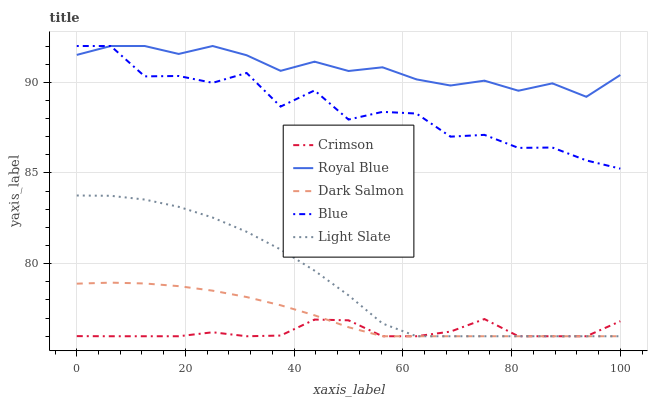Does Crimson have the minimum area under the curve?
Answer yes or no. Yes. Does Royal Blue have the maximum area under the curve?
Answer yes or no. Yes. Does Light Slate have the minimum area under the curve?
Answer yes or no. No. Does Light Slate have the maximum area under the curve?
Answer yes or no. No. Is Dark Salmon the smoothest?
Answer yes or no. Yes. Is Blue the roughest?
Answer yes or no. Yes. Is Royal Blue the smoothest?
Answer yes or no. No. Is Royal Blue the roughest?
Answer yes or no. No. Does Crimson have the lowest value?
Answer yes or no. Yes. Does Royal Blue have the lowest value?
Answer yes or no. No. Does Blue have the highest value?
Answer yes or no. Yes. Does Light Slate have the highest value?
Answer yes or no. No. Is Light Slate less than Royal Blue?
Answer yes or no. Yes. Is Royal Blue greater than Light Slate?
Answer yes or no. Yes. Does Crimson intersect Dark Salmon?
Answer yes or no. Yes. Is Crimson less than Dark Salmon?
Answer yes or no. No. Is Crimson greater than Dark Salmon?
Answer yes or no. No. Does Light Slate intersect Royal Blue?
Answer yes or no. No. 